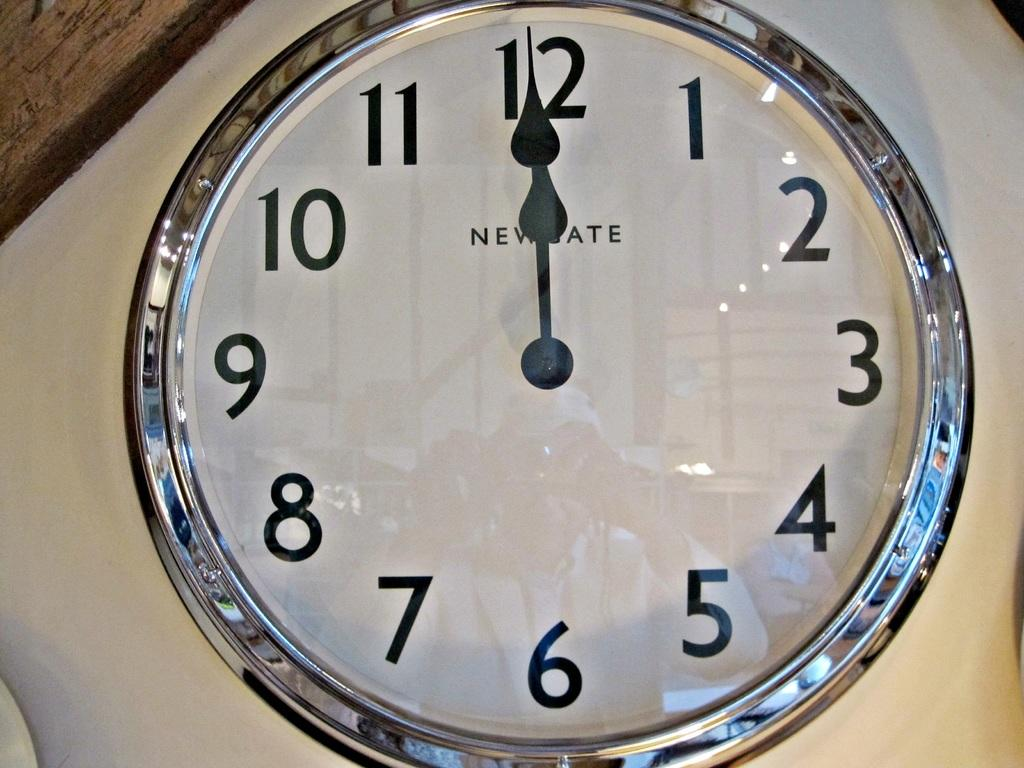<image>
Provide a brief description of the given image. A white watch face that says NEWGATE pointing 12 o'clock. 